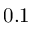<formula> <loc_0><loc_0><loc_500><loc_500>0 . 1</formula> 